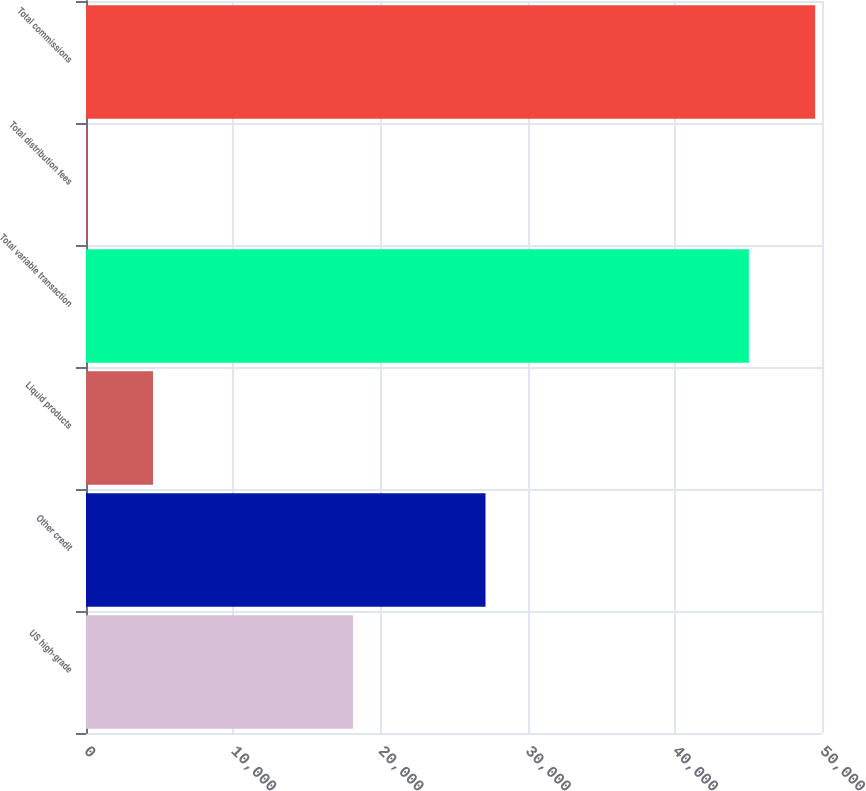<chart> <loc_0><loc_0><loc_500><loc_500><bar_chart><fcel>US high-grade<fcel>Other credit<fcel>Liquid products<fcel>Total variable transaction<fcel>Total distribution fees<fcel>Total commissions<nl><fcel>18137<fcel>27140<fcel>4554.2<fcel>45032<fcel>51<fcel>49535.2<nl></chart> 